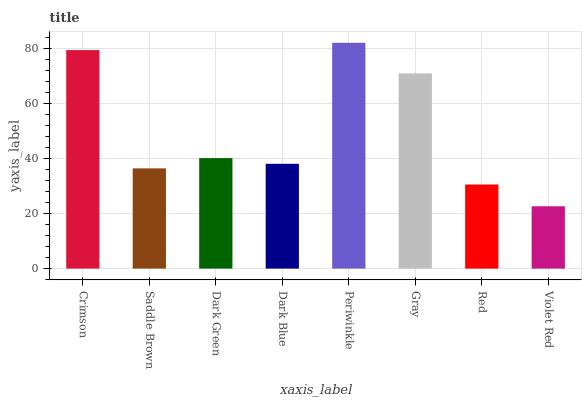Is Violet Red the minimum?
Answer yes or no. Yes. Is Periwinkle the maximum?
Answer yes or no. Yes. Is Saddle Brown the minimum?
Answer yes or no. No. Is Saddle Brown the maximum?
Answer yes or no. No. Is Crimson greater than Saddle Brown?
Answer yes or no. Yes. Is Saddle Brown less than Crimson?
Answer yes or no. Yes. Is Saddle Brown greater than Crimson?
Answer yes or no. No. Is Crimson less than Saddle Brown?
Answer yes or no. No. Is Dark Green the high median?
Answer yes or no. Yes. Is Dark Blue the low median?
Answer yes or no. Yes. Is Crimson the high median?
Answer yes or no. No. Is Crimson the low median?
Answer yes or no. No. 